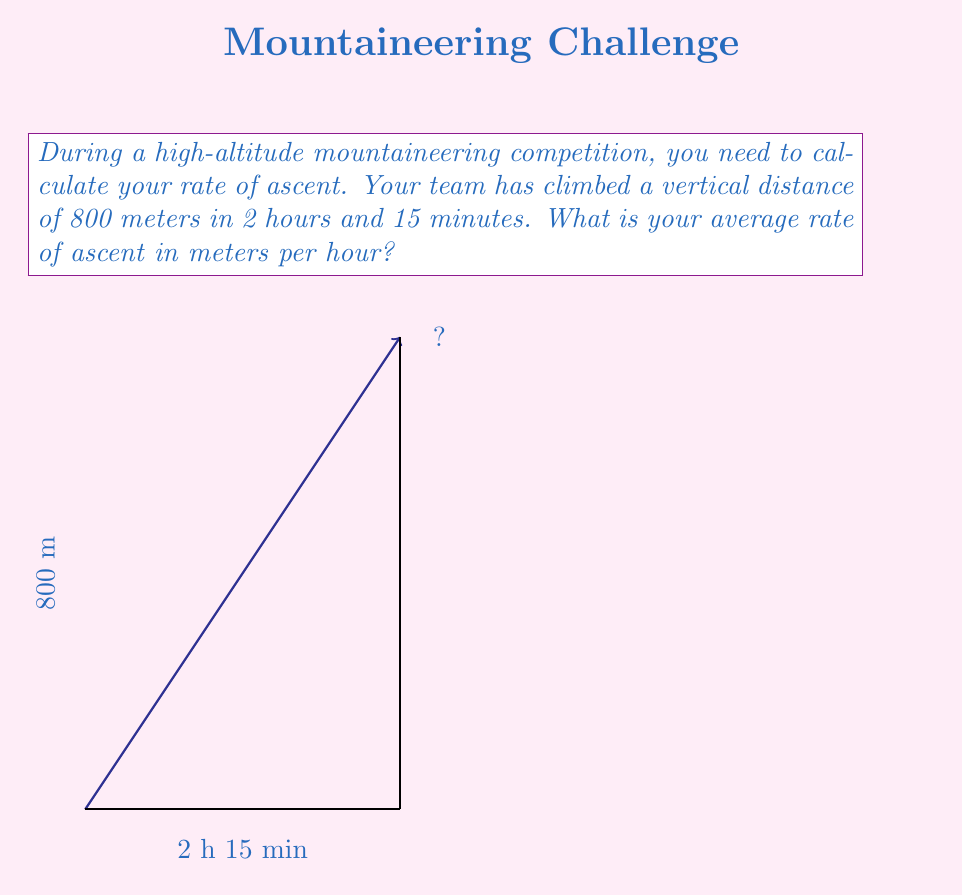Show me your answer to this math problem. To calculate the rate of ascent, we need to divide the distance climbed by the time taken. Let's break this down step-by-step:

1) First, we need to convert the time into hours:
   2 hours and 15 minutes = 2.25 hours
   
   $2 + \frac{15}{60} = 2 + 0.25 = 2.25$ hours

2) Now we have:
   Distance (d) = 800 meters
   Time (t) = 2.25 hours

3) The formula for rate (r) is:
   $r = \frac{d}{t}$

4) Substituting our values:
   $r = \frac{800}{2.25}$

5) Calculating:
   $r = 355.5555...$

6) Rounding to two decimal places:
   $r \approx 355.56$ meters per hour

Therefore, the average rate of ascent is approximately 355.56 meters per hour.
Answer: $355.56$ m/h 